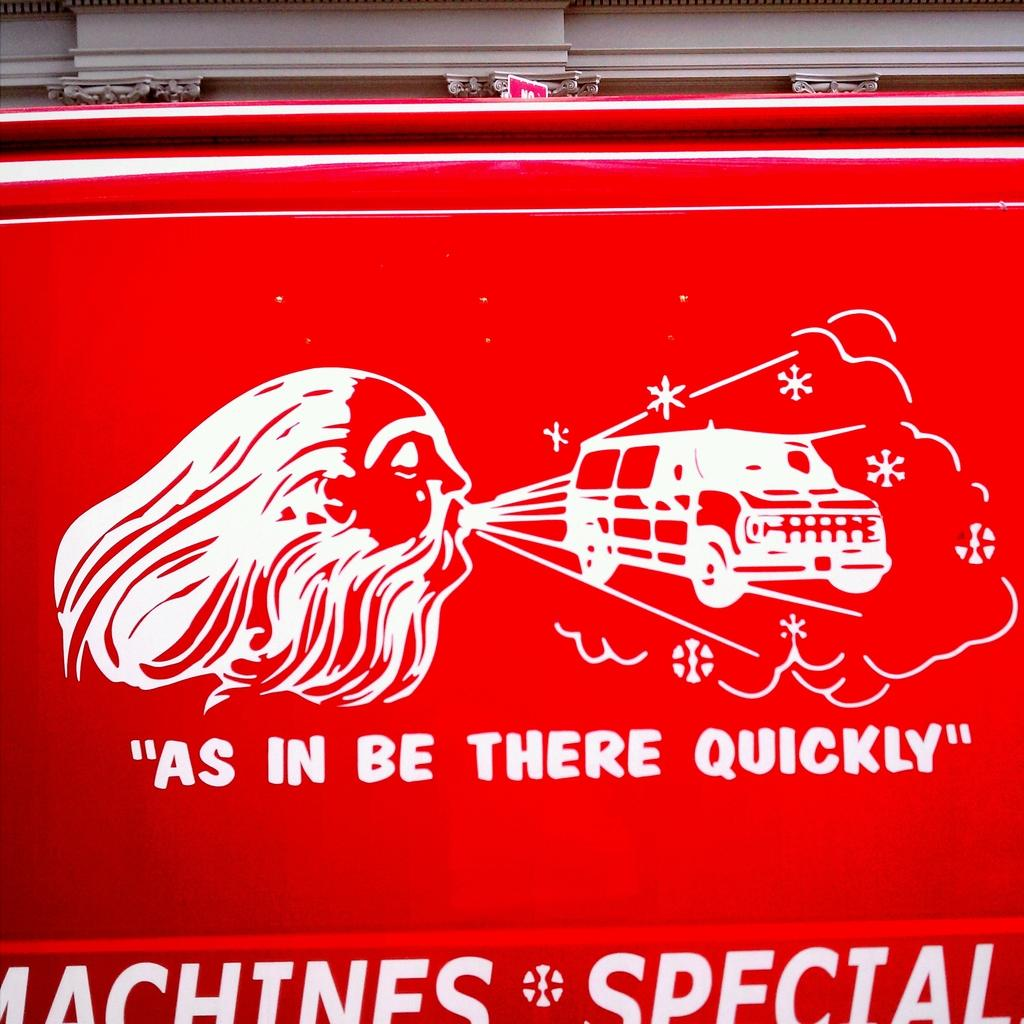What color is the prominent object in the image? There is a red object in the image. What features can be seen on the red object? The red object has logos and text written on it. What type of rhythm can be heard coming from the red object in the image? There is no indication of sound or rhythm in the image, as it features a red object with logos and text. 